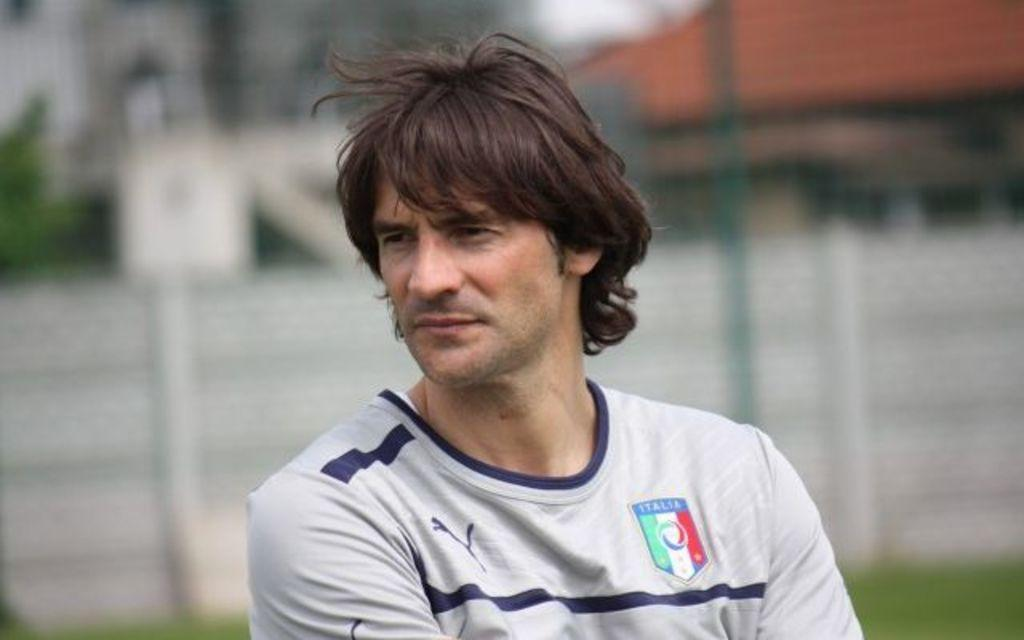<image>
Share a concise interpretation of the image provided. A middle aged man is standing outside, wearing a Puma brand, team jersey that says Italia. 